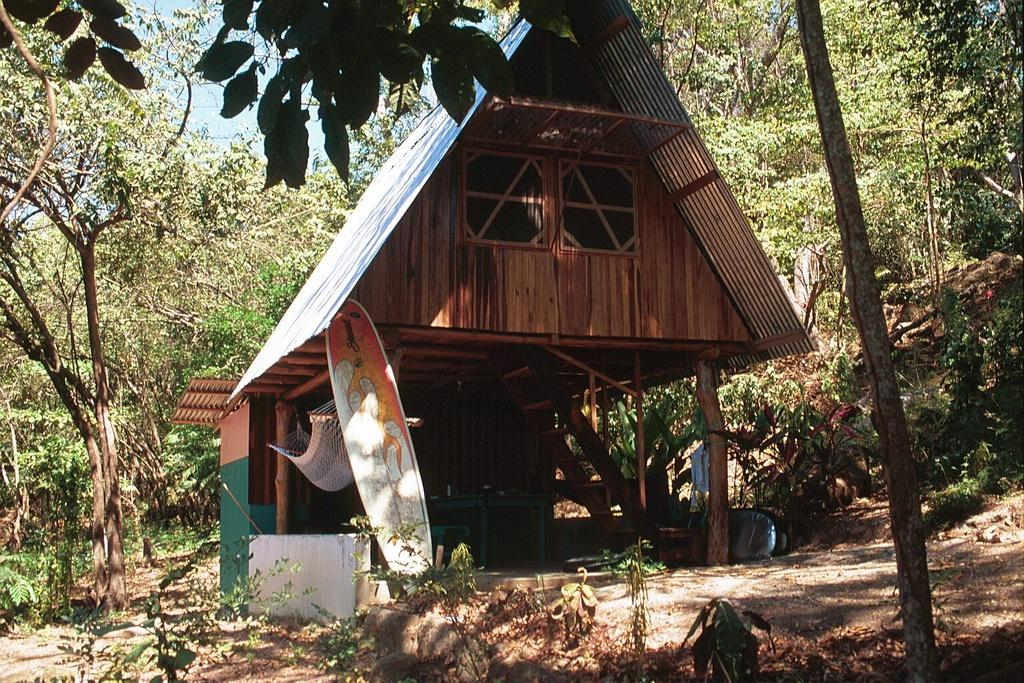What type of structure is in the image? There is a hut in the image. What feature is attached to the hut? The hut has a swing attached to it. How is the swing supported? The swing is attached to wooden trunks. What recreational item can be seen in front of the hut? There is a surfboard in front of the hut. What can be seen in the background of the image? There are plants and trees in the background of the image. What type of story is being told by the kitty in the image? There is no kitty present in the image, so no story can be told by a kitty. 